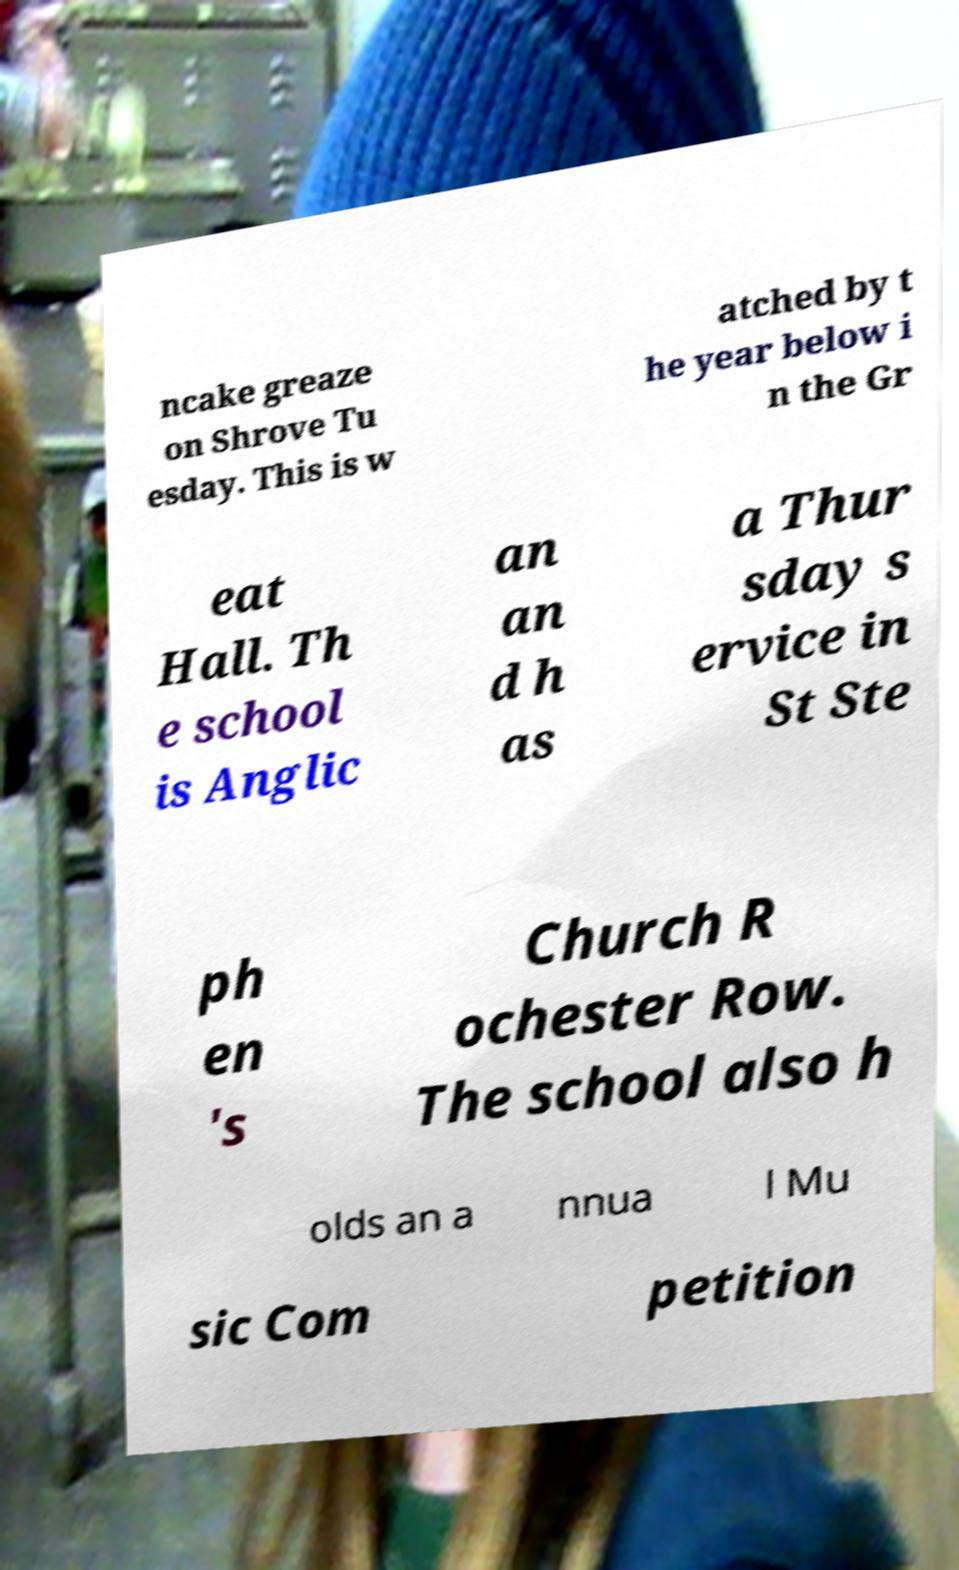I need the written content from this picture converted into text. Can you do that? ncake greaze on Shrove Tu esday. This is w atched by t he year below i n the Gr eat Hall. Th e school is Anglic an an d h as a Thur sday s ervice in St Ste ph en 's Church R ochester Row. The school also h olds an a nnua l Mu sic Com petition 